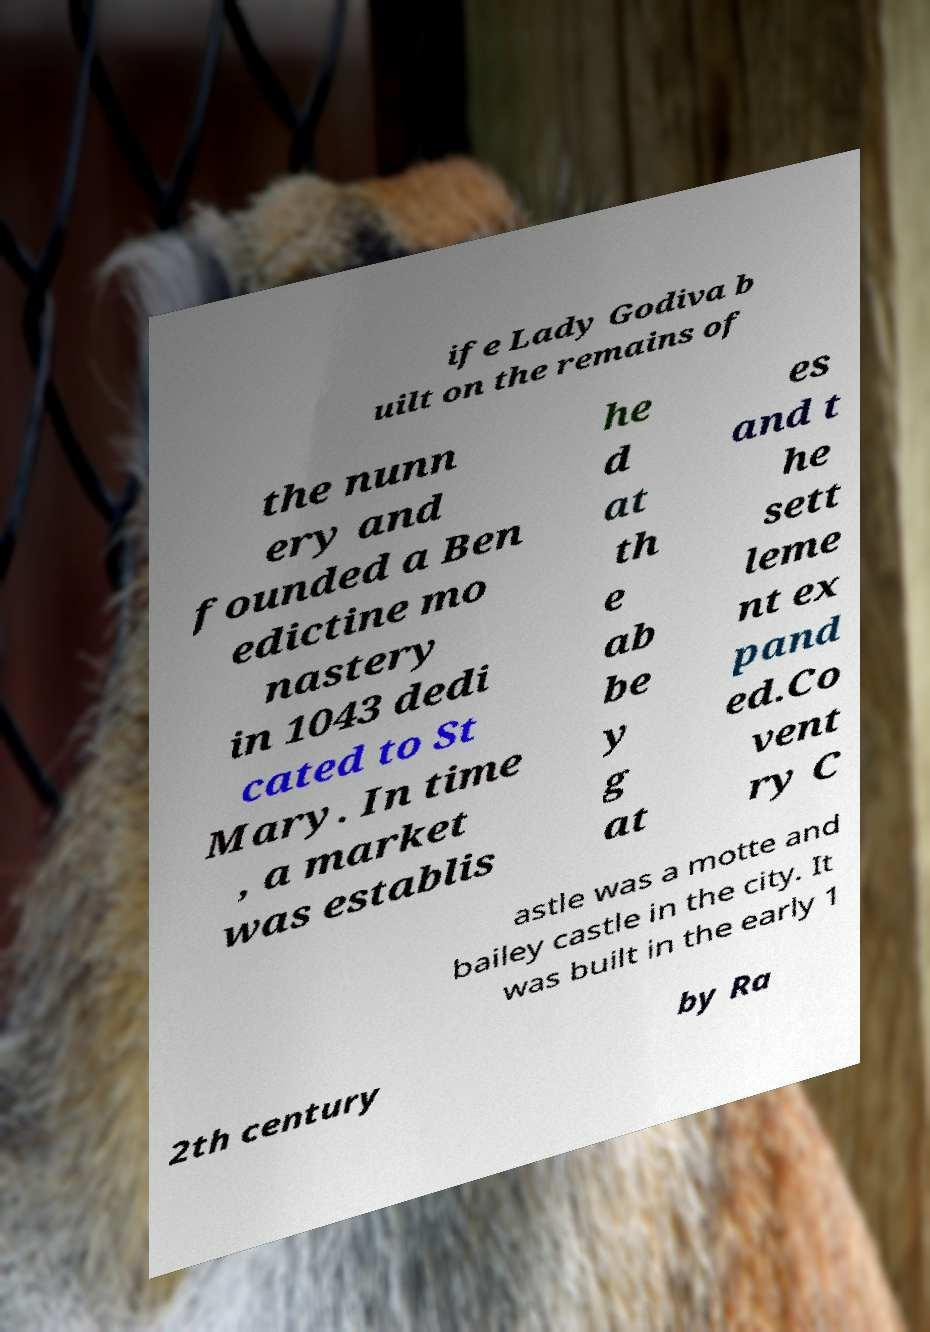Could you extract and type out the text from this image? ife Lady Godiva b uilt on the remains of the nunn ery and founded a Ben edictine mo nastery in 1043 dedi cated to St Mary. In time , a market was establis he d at th e ab be y g at es and t he sett leme nt ex pand ed.Co vent ry C astle was a motte and bailey castle in the city. It was built in the early 1 2th century by Ra 